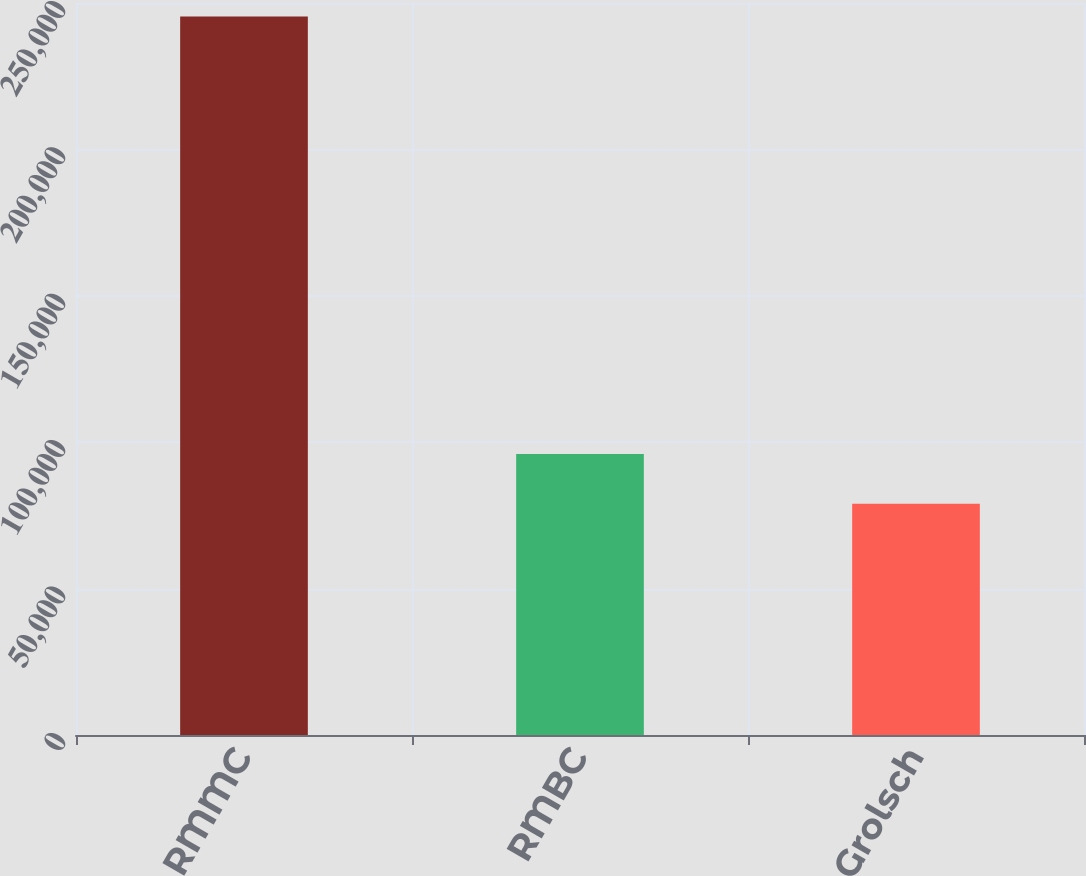Convert chart. <chart><loc_0><loc_0><loc_500><loc_500><bar_chart><fcel>RMMC<fcel>RMBC<fcel>Grolsch<nl><fcel>245371<fcel>96009<fcel>79007<nl></chart> 